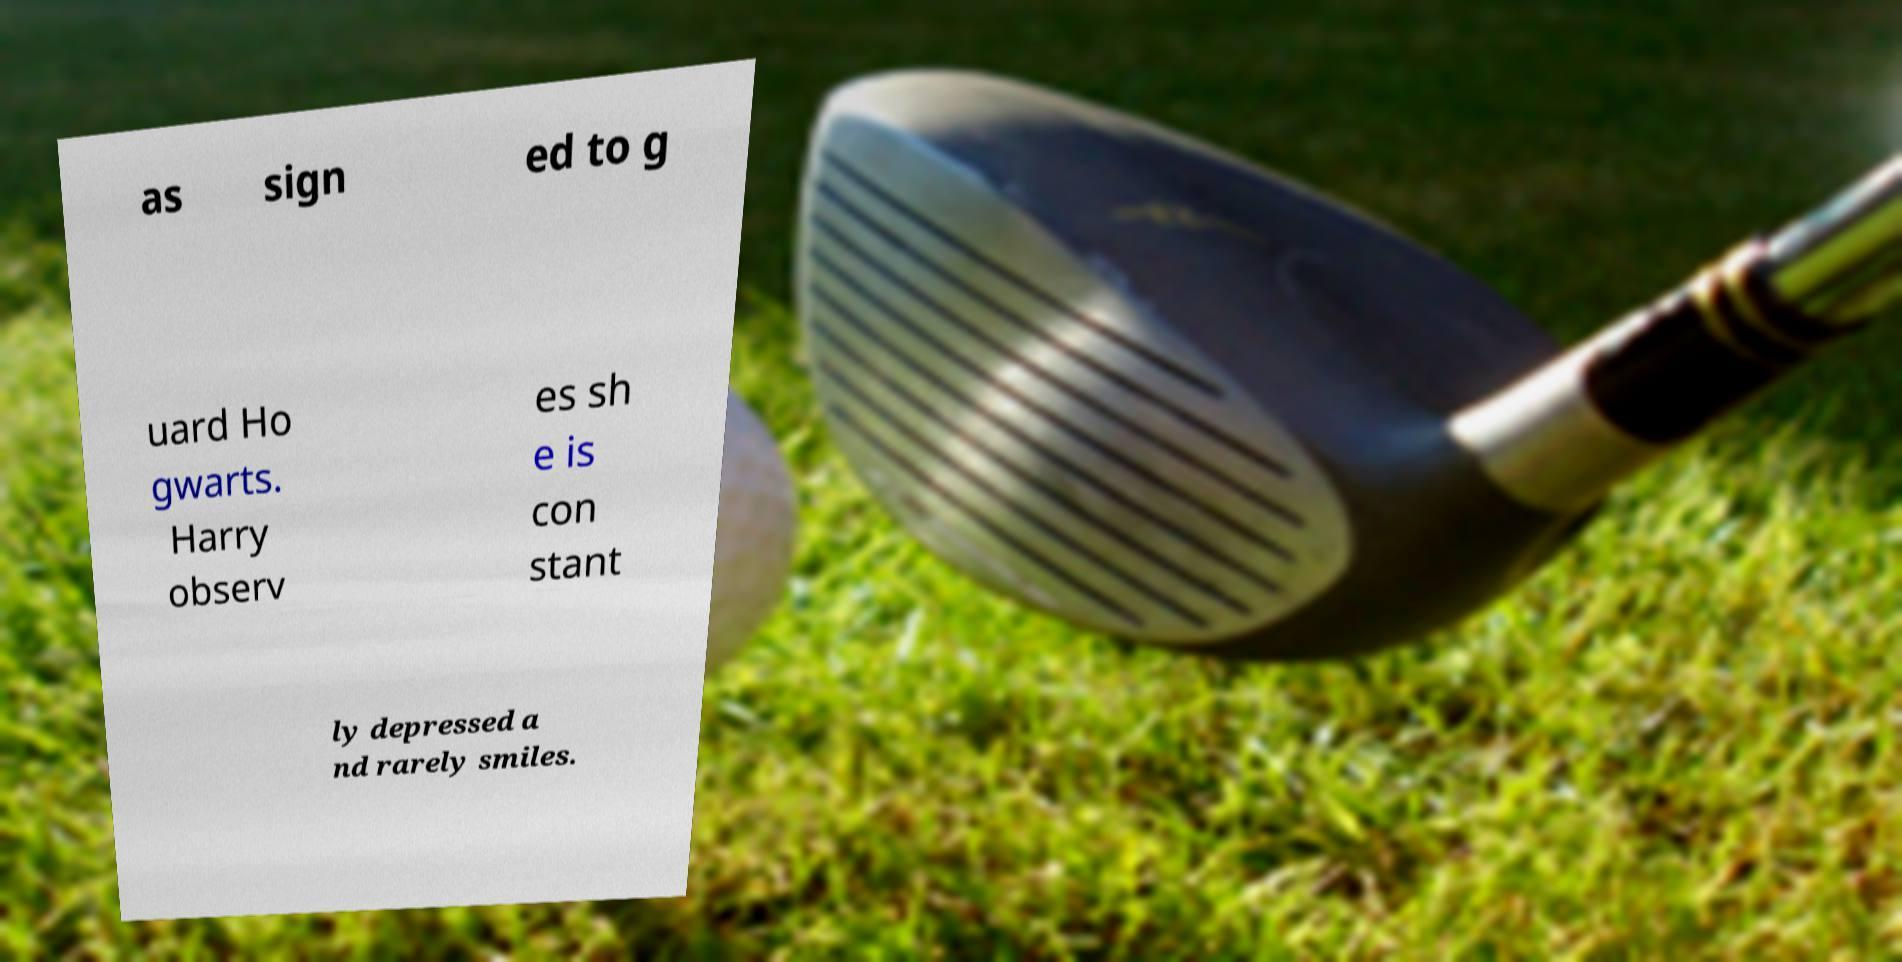Please read and relay the text visible in this image. What does it say? as sign ed to g uard Ho gwarts. Harry observ es sh e is con stant ly depressed a nd rarely smiles. 